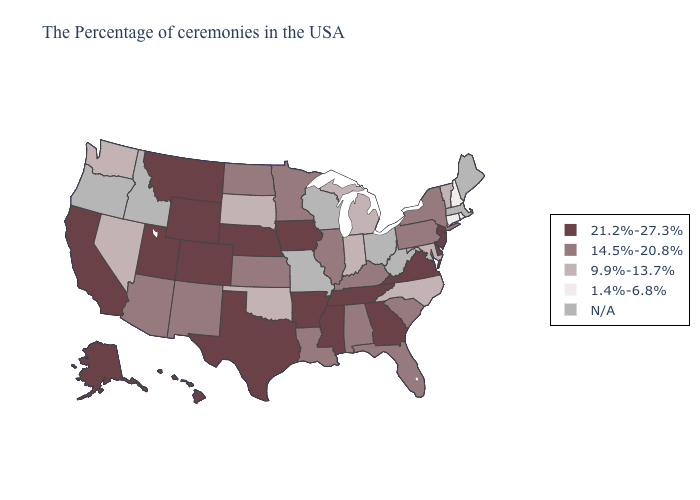Which states have the lowest value in the Northeast?
Be succinct. Rhode Island, New Hampshire, Connecticut. What is the value of Ohio?
Short answer required. N/A. Does the map have missing data?
Write a very short answer. Yes. What is the lowest value in the Northeast?
Concise answer only. 1.4%-6.8%. What is the highest value in the South ?
Write a very short answer. 21.2%-27.3%. Name the states that have a value in the range 21.2%-27.3%?
Short answer required. New Jersey, Delaware, Virginia, Georgia, Tennessee, Mississippi, Arkansas, Iowa, Nebraska, Texas, Wyoming, Colorado, Utah, Montana, California, Alaska, Hawaii. What is the lowest value in the MidWest?
Give a very brief answer. 9.9%-13.7%. What is the highest value in the USA?
Answer briefly. 21.2%-27.3%. Which states have the highest value in the USA?
Give a very brief answer. New Jersey, Delaware, Virginia, Georgia, Tennessee, Mississippi, Arkansas, Iowa, Nebraska, Texas, Wyoming, Colorado, Utah, Montana, California, Alaska, Hawaii. Name the states that have a value in the range N/A?
Quick response, please. Maine, Massachusetts, West Virginia, Ohio, Wisconsin, Missouri, Idaho, Oregon. What is the value of Florida?
Keep it brief. 14.5%-20.8%. Is the legend a continuous bar?
Write a very short answer. No. What is the value of Ohio?
Quick response, please. N/A. Which states have the lowest value in the USA?
Answer briefly. Rhode Island, New Hampshire, Connecticut. 